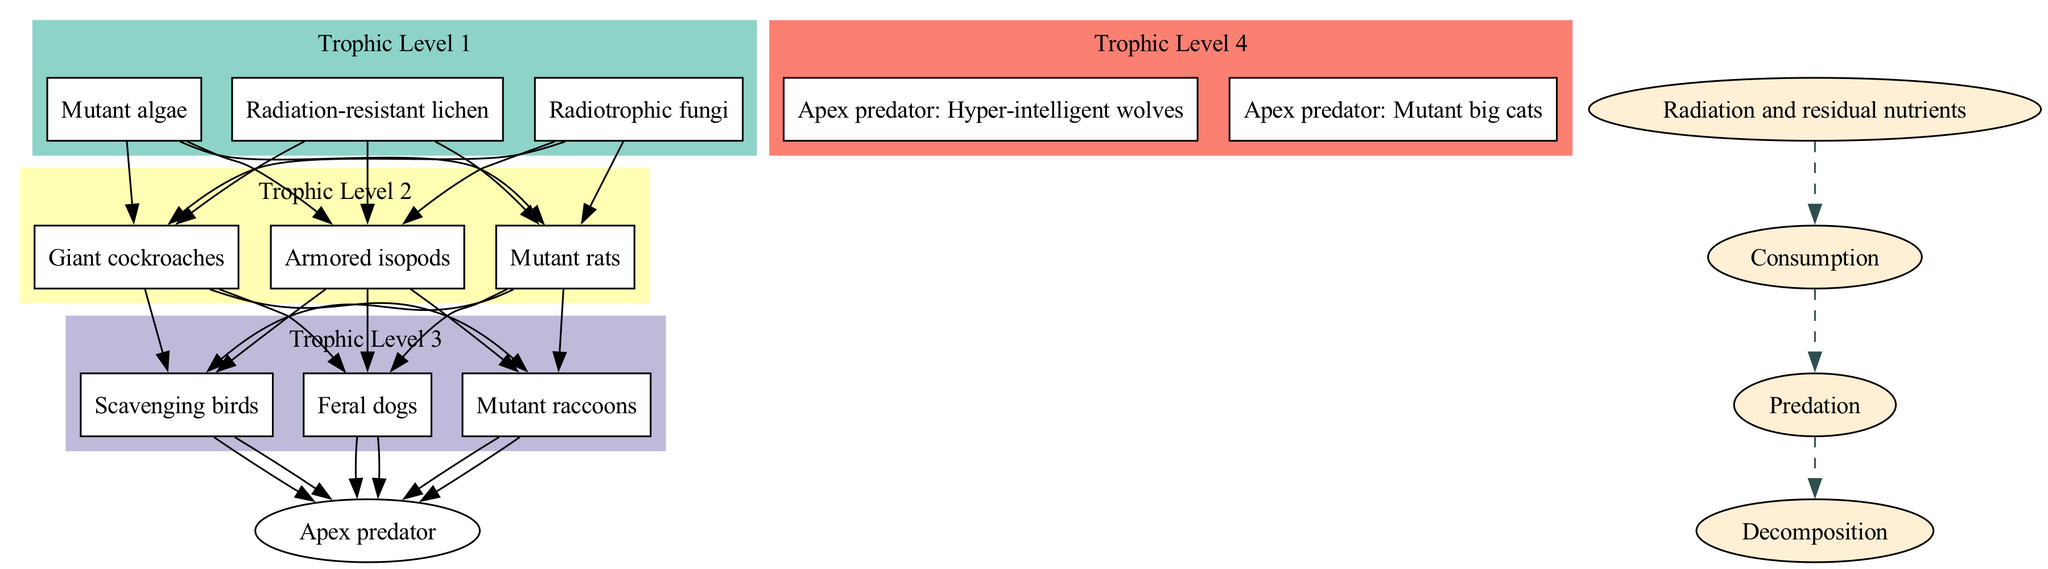What are the organisms in Trophic Level 1? According to the diagram, Trophic Level 1 is represented by three organisms: Radiotrophic fungi, Mutant algae, and Radiation-resistant lichen. These organisms are the producers, forming the base of the food chain.
Answer: Radiotrophic fungi, Mutant algae, Radiation-resistant lichen How many organisms are at Trophic Level 3? The diagram indicates that Trophic Level 3 contains three organisms: Scavenging birds, Feral dogs, and Mutant raccoons. Counting these gives a total of three organisms at this level.
Answer: 3 What is the primary energy flow in this food chain? The diagram lists energy flow components that start from "Radiation and residual nutrients" and proceed to "Consumption," "Predation," and "Decomposition," signifying the main processes taking place in the food chain.
Answer: Radiation and residual nutrients Which organisms are apex predators in this food chain? Trophic Level 4 contains the apex predators: Hyper-intelligent wolves and Mutant big cats. These species are the top of the food chain, indicating they have no natural predators within this ecological structure.
Answer: Hyper-intelligent wolves, Mutant big cats What is the relationship between Mutant rats and Scavenging birds? Mutant rats are located in Trophic Level 2, while Scavenging birds are in Trophic Level 3. The diagram shows a direct predatory relationship from the lower level (Mutant rats) to the upper level (Scavenging birds), indicating that Scavenging birds may prey on Mutant rats.
Answer: Predation 